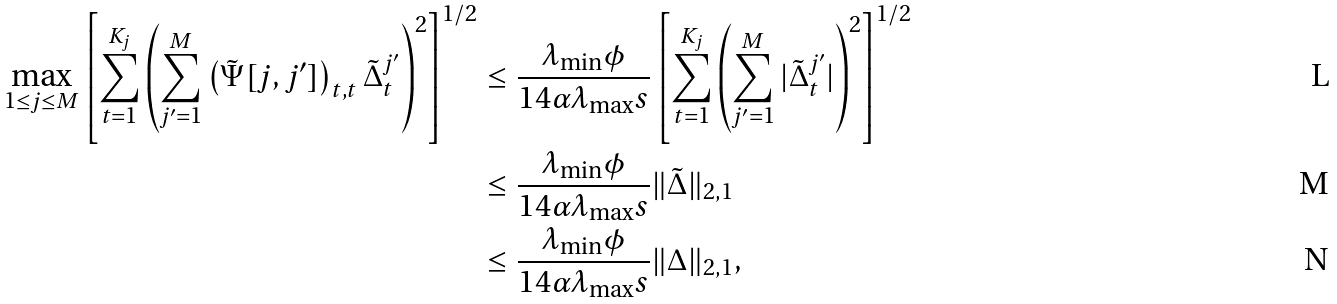Convert formula to latex. <formula><loc_0><loc_0><loc_500><loc_500>\max _ { 1 \leq j \leq M } \left [ \sum _ { t = 1 } ^ { K _ { j } } \left ( \sum _ { j ^ { \prime } = 1 } ^ { M } \left ( \tilde { \Psi } [ j , j ^ { \prime } ] \right ) _ { t , t } \tilde { \Delta } _ { t } ^ { j ^ { \prime } } \right ) ^ { 2 } \right ] ^ { 1 / 2 } & \leq \frac { \lambda _ { \min } \phi } { 1 4 \alpha \lambda _ { \max } s } \left [ \sum _ { t = 1 } ^ { K _ { j } } \left ( \sum _ { j ^ { \prime } = 1 } ^ { M } | \tilde { \Delta } _ { t } ^ { j ^ { \prime } } | \right ) ^ { 2 } \right ] ^ { 1 / 2 } \\ & \leq \frac { \lambda _ { \min } \phi } { 1 4 \alpha \lambda _ { \max } s } \| \tilde { \Delta } \| _ { 2 , 1 } \\ & \leq \frac { \lambda _ { \min } \phi } { 1 4 \alpha \lambda _ { \max } s } \| \Delta \| _ { 2 , 1 } ,</formula> 